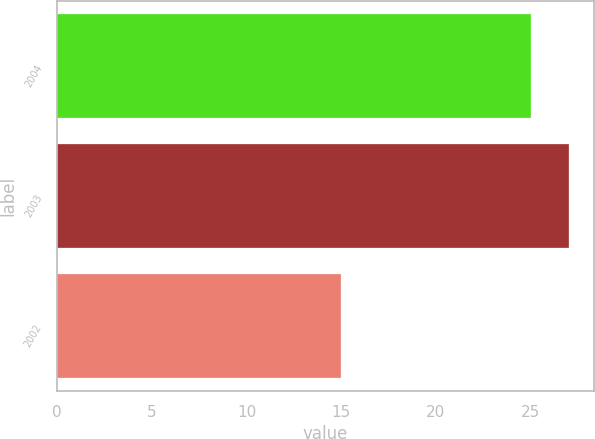Convert chart. <chart><loc_0><loc_0><loc_500><loc_500><bar_chart><fcel>2004<fcel>2003<fcel>2002<nl><fcel>25<fcel>27<fcel>15<nl></chart> 